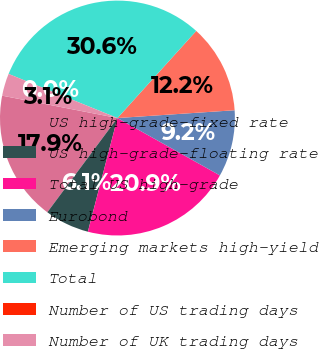Convert chart. <chart><loc_0><loc_0><loc_500><loc_500><pie_chart><fcel>US high-grade-fixed rate<fcel>US high-grade-floating rate<fcel>Total US high-grade<fcel>Eurobond<fcel>Emerging markets high-yield<fcel>Total<fcel>Number of US trading days<fcel>Number of UK trading days<nl><fcel>17.87%<fcel>6.13%<fcel>20.93%<fcel>9.18%<fcel>12.24%<fcel>30.57%<fcel>0.01%<fcel>3.07%<nl></chart> 